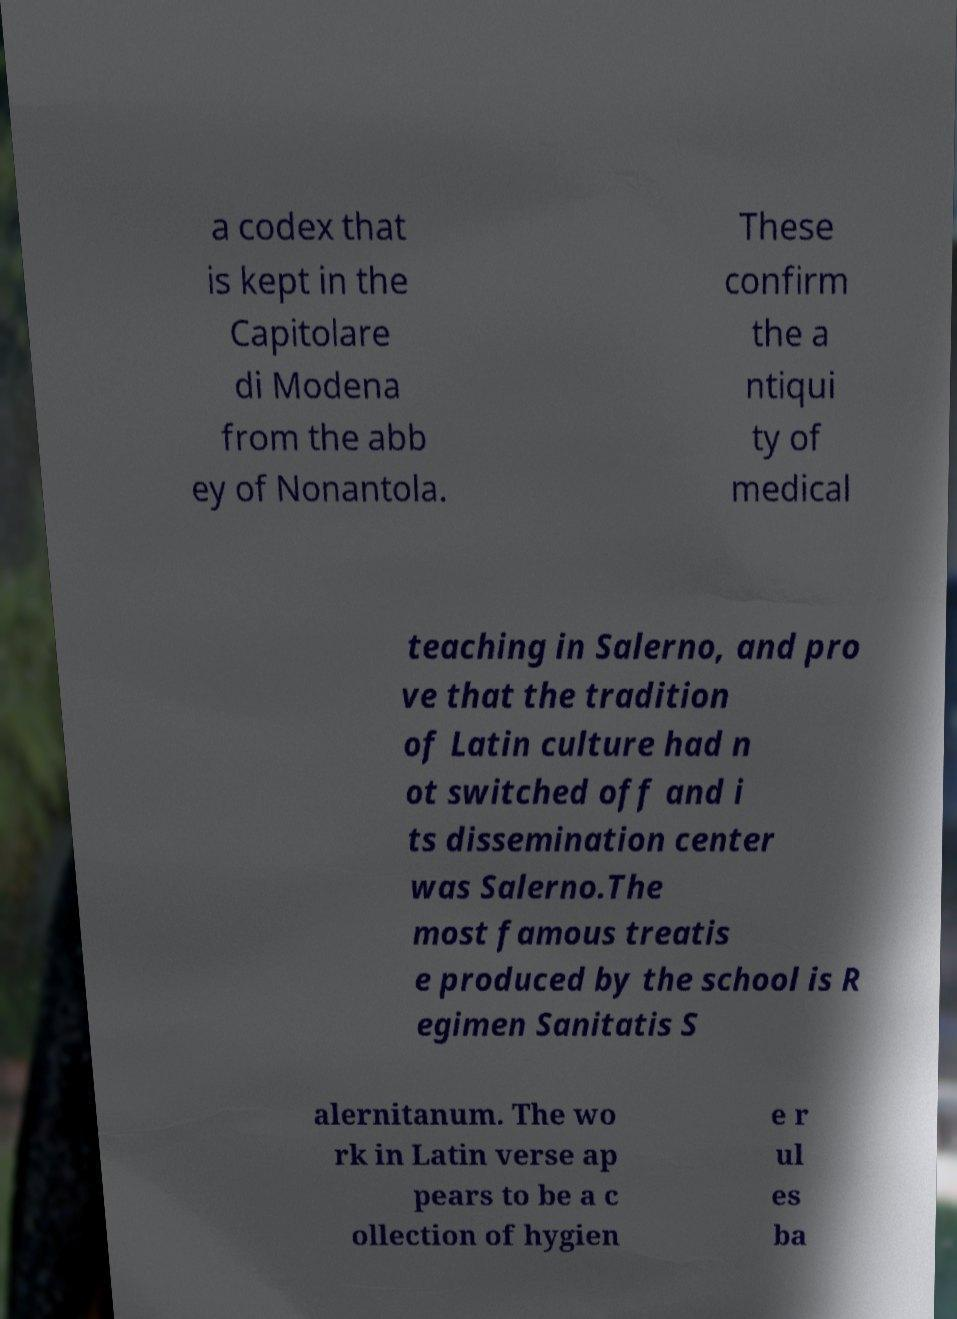Can you read and provide the text displayed in the image?This photo seems to have some interesting text. Can you extract and type it out for me? a codex that is kept in the Capitolare di Modena from the abb ey of Nonantola. These confirm the a ntiqui ty of medical teaching in Salerno, and pro ve that the tradition of Latin culture had n ot switched off and i ts dissemination center was Salerno.The most famous treatis e produced by the school is R egimen Sanitatis S alernitanum. The wo rk in Latin verse ap pears to be a c ollection of hygien e r ul es ba 